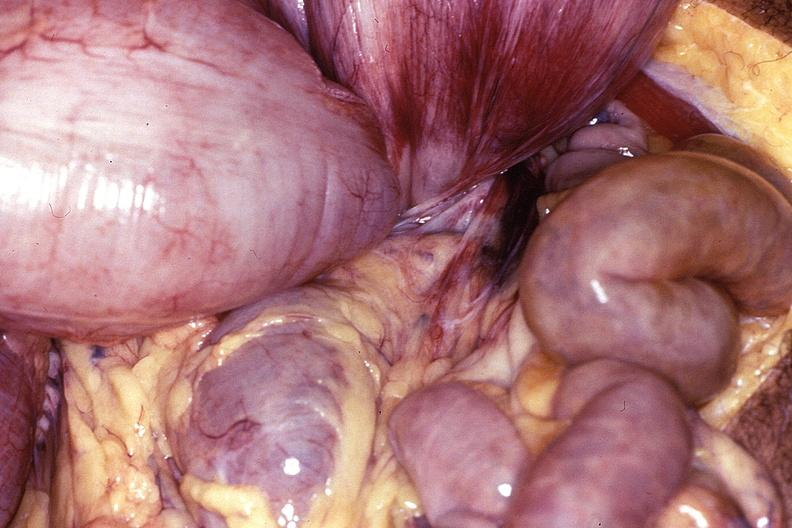s gastrointestinal present?
Answer the question using a single word or phrase. Yes 